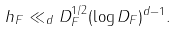<formula> <loc_0><loc_0><loc_500><loc_500>h _ { F } \ll _ { d } D _ { F } ^ { 1 / 2 } ( \log D _ { F } ) ^ { d - 1 } .</formula> 